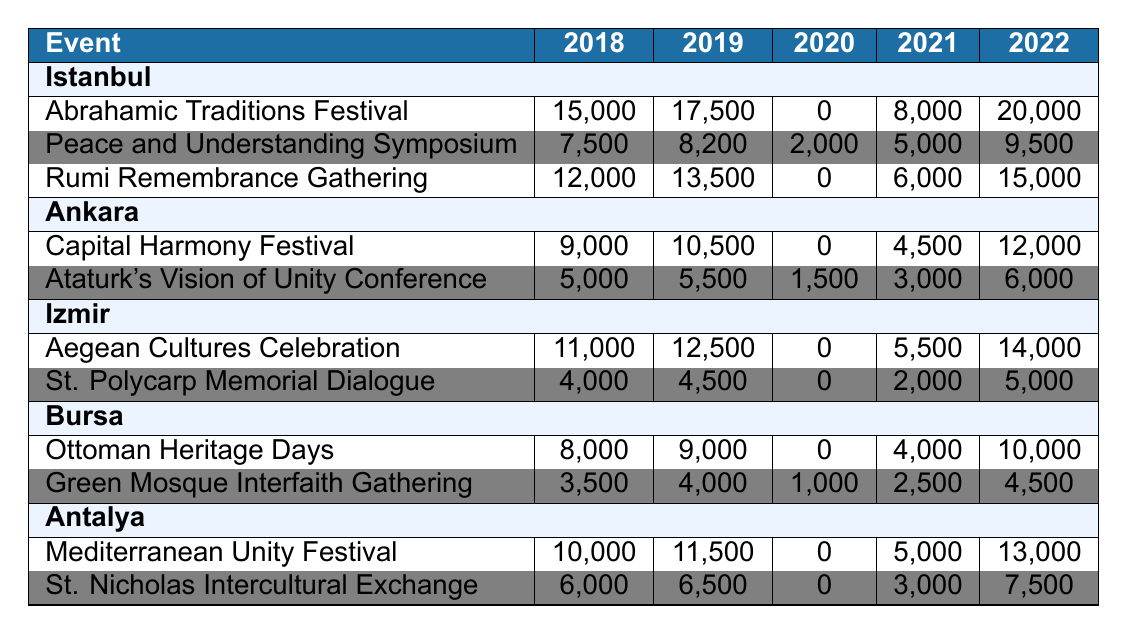What was the highest attendance at the Abrahamic Traditions Festival? The highest attendance at the Abrahamic Traditions Festival was in 2022 with 20,000 participants.
Answer: 20,000 In which year did the Rumi Remembrance Gathering have no attendees? The Rumi Remembrance Gathering had no attendees in 2020.
Answer: 2020 Which event in Ankara had the lowest attendance in 2020? The Capital Harmony Festival had the lowest attendance in 2020 with 0 participants, as did the Ataturk's Vision of Unity Conference.
Answer: Both events had 0 attendees What is the total attendance for the Mediterranean Unity Festival over the five years? The total attendance for the Mediterranean Unity Festival is calculated by adding the attendance from each year: 10,000 + 11,500 + 0 + 5,000 + 13,000 = 39,500.
Answer: 39,500 Did the attendance at the Peace and Understanding Symposium increase every year? No, the attendance fluctuated with an increase from 2018 to 2019, a decrease in 2020, and then an increase in 2021 and 2022.
Answer: No What is the average attendance for the Aegean Cultures Celebration? The average attendance is calculated by adding 11,000 + 12,500 + 0 + 5,500 + 14,000 = 43,000 and then dividing by 5, resulting in an average of 8,600.
Answer: 8,600 Which city had the highest total attendance across all events? By calculating the total for each city, Istanbul had the highest total with 15,000 + 7,500 + 12,000 + 17,500 + 8,200 + 13,500 + 0 + 6,000 + 15,000 = 50,700.
Answer: Istanbul How many events in Bursa saw participation numbers decrease from 2018 to 2022? The Ottoman Heritage Days and Green Mosque Interfaith Gathering both showed a decrease in attendance from 2018 to subsequent years up until 2021 but increased by 2022.
Answer: 2 events What was the total attendance at all interfaith festivals in 2019? The total attendance for 2019 is calculated by adding all the attendance figures: 17,500 (Istanbul: Abrahamic) + 8,200 (Istanbul: Peace) + 13,500 (Istanbul: Rumi) + 10,500 (Ankara: Capital) + 5,500 (Ankara: Ataturk) + 12,500 (Izmir: Aegean) + 4,500 (Izmir: Polycarp) + 9,000 (Bursa: Ottoman) + 4,000 (Bursa: Green Mosque) + 11,500 (Antalya: Mediterranean) + 6,500 (Antalya: St. Nicholas) = 88,700 total attendance.
Answer: 88,700 Was there a year when no events had participants in Istanbul? Yes, in 2020, the Abrahamic Traditions Festival and Rumi Remembrance Gathering had 0 attendees.
Answer: Yes 